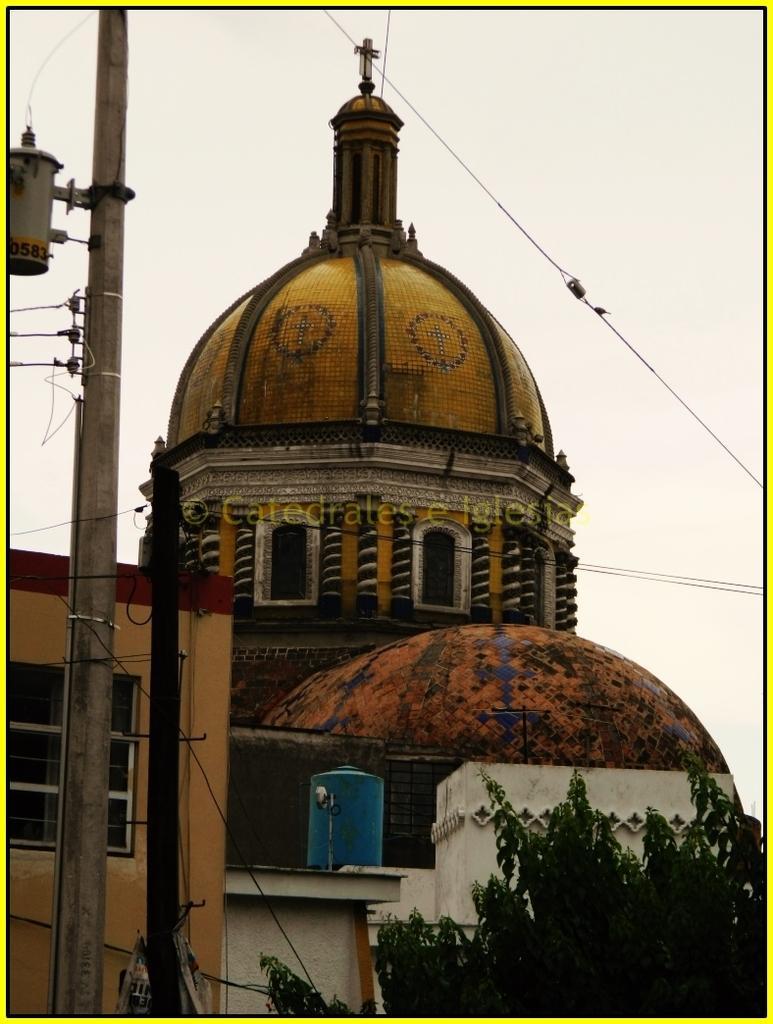Could you give a brief overview of what you see in this image? In this picture I can see buildings, a tree, couple of poles and a cloudy sky. 